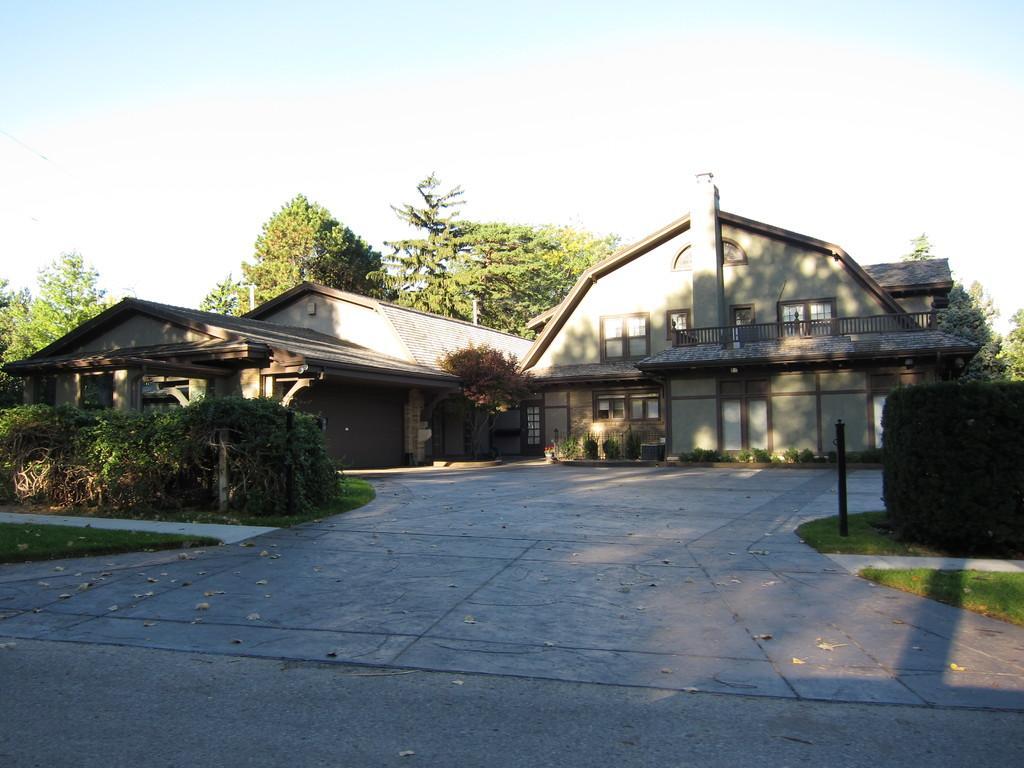In one or two sentences, can you explain what this image depicts? In this image there is a house, behind the house there are trees, in front of the house there are plants, bushes and a metal rod. 